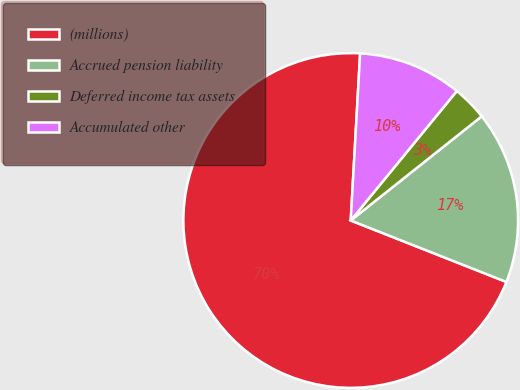Convert chart to OTSL. <chart><loc_0><loc_0><loc_500><loc_500><pie_chart><fcel>(millions)<fcel>Accrued pension liability<fcel>Deferred income tax assets<fcel>Accumulated other<nl><fcel>69.91%<fcel>16.68%<fcel>3.38%<fcel>10.03%<nl></chart> 